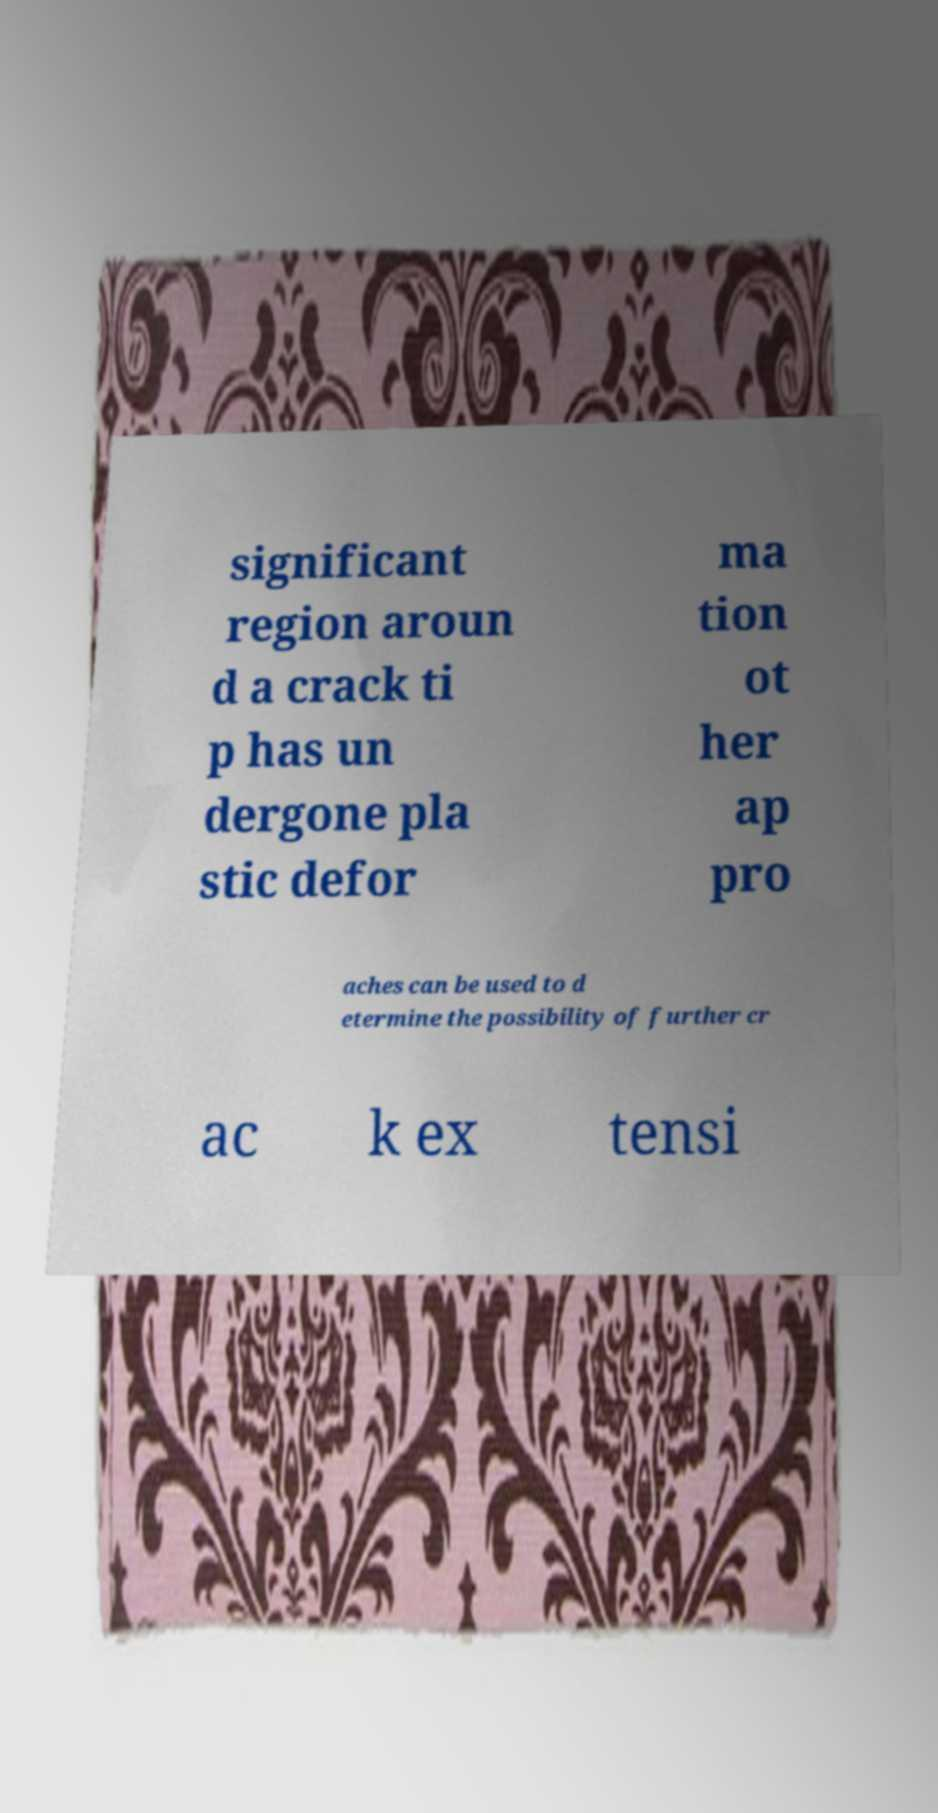Can you read and provide the text displayed in the image?This photo seems to have some interesting text. Can you extract and type it out for me? significant region aroun d a crack ti p has un dergone pla stic defor ma tion ot her ap pro aches can be used to d etermine the possibility of further cr ac k ex tensi 